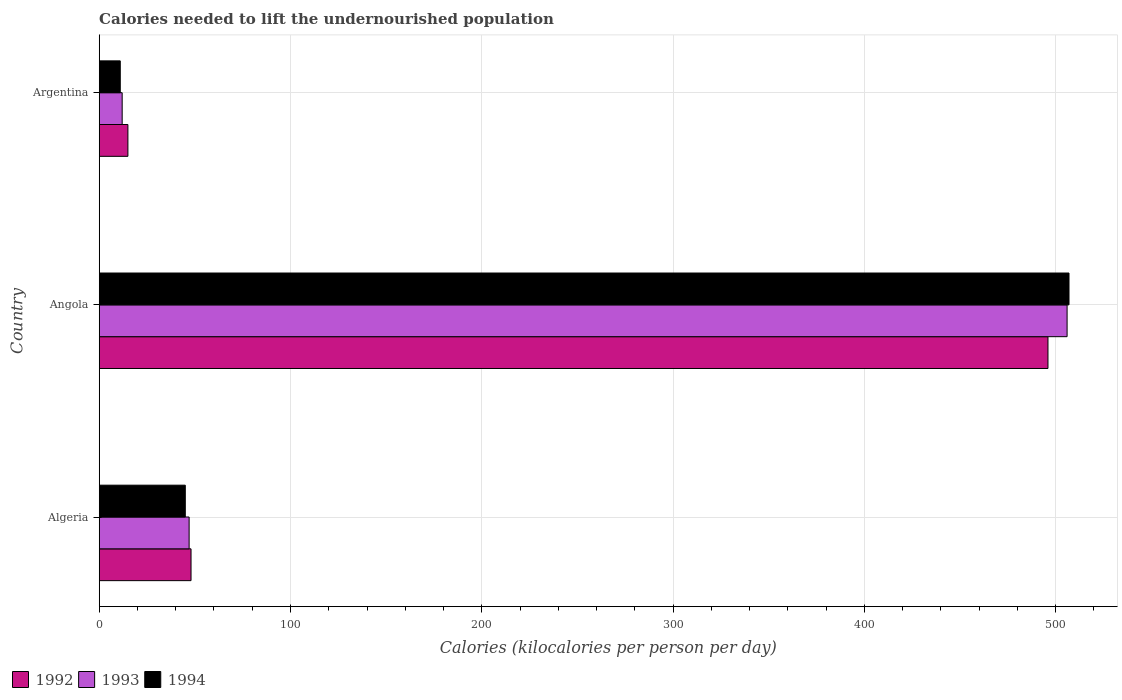How many groups of bars are there?
Ensure brevity in your answer.  3. Are the number of bars on each tick of the Y-axis equal?
Keep it short and to the point. Yes. How many bars are there on the 2nd tick from the top?
Provide a short and direct response. 3. How many bars are there on the 3rd tick from the bottom?
Offer a terse response. 3. In how many cases, is the number of bars for a given country not equal to the number of legend labels?
Give a very brief answer. 0. Across all countries, what is the maximum total calories needed to lift the undernourished population in 1994?
Ensure brevity in your answer.  507. Across all countries, what is the minimum total calories needed to lift the undernourished population in 1993?
Give a very brief answer. 12. In which country was the total calories needed to lift the undernourished population in 1992 maximum?
Your answer should be very brief. Angola. What is the total total calories needed to lift the undernourished population in 1994 in the graph?
Provide a short and direct response. 563. What is the difference between the total calories needed to lift the undernourished population in 1993 in Angola and that in Argentina?
Offer a very short reply. 494. What is the difference between the total calories needed to lift the undernourished population in 1992 in Algeria and the total calories needed to lift the undernourished population in 1993 in Angola?
Your answer should be compact. -458. What is the average total calories needed to lift the undernourished population in 1993 per country?
Offer a very short reply. 188.33. In how many countries, is the total calories needed to lift the undernourished population in 1994 greater than 200 kilocalories?
Ensure brevity in your answer.  1. What is the ratio of the total calories needed to lift the undernourished population in 1994 in Angola to that in Argentina?
Ensure brevity in your answer.  46.09. Is the total calories needed to lift the undernourished population in 1994 in Algeria less than that in Argentina?
Your answer should be compact. No. What is the difference between the highest and the second highest total calories needed to lift the undernourished population in 1994?
Give a very brief answer. 462. What is the difference between the highest and the lowest total calories needed to lift the undernourished population in 1993?
Your response must be concise. 494. What does the 2nd bar from the bottom in Algeria represents?
Offer a very short reply. 1993. Is it the case that in every country, the sum of the total calories needed to lift the undernourished population in 1993 and total calories needed to lift the undernourished population in 1994 is greater than the total calories needed to lift the undernourished population in 1992?
Your response must be concise. Yes. How many bars are there?
Make the answer very short. 9. Are all the bars in the graph horizontal?
Your answer should be very brief. Yes. How many countries are there in the graph?
Give a very brief answer. 3. What is the difference between two consecutive major ticks on the X-axis?
Provide a short and direct response. 100. Does the graph contain grids?
Keep it short and to the point. Yes. How many legend labels are there?
Your answer should be very brief. 3. How are the legend labels stacked?
Give a very brief answer. Horizontal. What is the title of the graph?
Provide a short and direct response. Calories needed to lift the undernourished population. What is the label or title of the X-axis?
Ensure brevity in your answer.  Calories (kilocalories per person per day). What is the Calories (kilocalories per person per day) in 1993 in Algeria?
Give a very brief answer. 47. What is the Calories (kilocalories per person per day) of 1992 in Angola?
Offer a very short reply. 496. What is the Calories (kilocalories per person per day) of 1993 in Angola?
Keep it short and to the point. 506. What is the Calories (kilocalories per person per day) of 1994 in Angola?
Your answer should be compact. 507. What is the Calories (kilocalories per person per day) of 1992 in Argentina?
Offer a terse response. 15. Across all countries, what is the maximum Calories (kilocalories per person per day) of 1992?
Provide a succinct answer. 496. Across all countries, what is the maximum Calories (kilocalories per person per day) of 1993?
Make the answer very short. 506. Across all countries, what is the maximum Calories (kilocalories per person per day) of 1994?
Make the answer very short. 507. What is the total Calories (kilocalories per person per day) of 1992 in the graph?
Ensure brevity in your answer.  559. What is the total Calories (kilocalories per person per day) in 1993 in the graph?
Give a very brief answer. 565. What is the total Calories (kilocalories per person per day) of 1994 in the graph?
Provide a succinct answer. 563. What is the difference between the Calories (kilocalories per person per day) of 1992 in Algeria and that in Angola?
Ensure brevity in your answer.  -448. What is the difference between the Calories (kilocalories per person per day) in 1993 in Algeria and that in Angola?
Make the answer very short. -459. What is the difference between the Calories (kilocalories per person per day) in 1994 in Algeria and that in Angola?
Provide a short and direct response. -462. What is the difference between the Calories (kilocalories per person per day) in 1993 in Algeria and that in Argentina?
Provide a short and direct response. 35. What is the difference between the Calories (kilocalories per person per day) of 1994 in Algeria and that in Argentina?
Offer a terse response. 34. What is the difference between the Calories (kilocalories per person per day) in 1992 in Angola and that in Argentina?
Offer a terse response. 481. What is the difference between the Calories (kilocalories per person per day) of 1993 in Angola and that in Argentina?
Your answer should be compact. 494. What is the difference between the Calories (kilocalories per person per day) in 1994 in Angola and that in Argentina?
Make the answer very short. 496. What is the difference between the Calories (kilocalories per person per day) of 1992 in Algeria and the Calories (kilocalories per person per day) of 1993 in Angola?
Offer a terse response. -458. What is the difference between the Calories (kilocalories per person per day) in 1992 in Algeria and the Calories (kilocalories per person per day) in 1994 in Angola?
Your answer should be compact. -459. What is the difference between the Calories (kilocalories per person per day) in 1993 in Algeria and the Calories (kilocalories per person per day) in 1994 in Angola?
Make the answer very short. -460. What is the difference between the Calories (kilocalories per person per day) in 1992 in Algeria and the Calories (kilocalories per person per day) in 1993 in Argentina?
Offer a very short reply. 36. What is the difference between the Calories (kilocalories per person per day) of 1992 in Algeria and the Calories (kilocalories per person per day) of 1994 in Argentina?
Provide a succinct answer. 37. What is the difference between the Calories (kilocalories per person per day) in 1992 in Angola and the Calories (kilocalories per person per day) in 1993 in Argentina?
Your response must be concise. 484. What is the difference between the Calories (kilocalories per person per day) in 1992 in Angola and the Calories (kilocalories per person per day) in 1994 in Argentina?
Your response must be concise. 485. What is the difference between the Calories (kilocalories per person per day) of 1993 in Angola and the Calories (kilocalories per person per day) of 1994 in Argentina?
Give a very brief answer. 495. What is the average Calories (kilocalories per person per day) in 1992 per country?
Keep it short and to the point. 186.33. What is the average Calories (kilocalories per person per day) in 1993 per country?
Provide a succinct answer. 188.33. What is the average Calories (kilocalories per person per day) of 1994 per country?
Your response must be concise. 187.67. What is the difference between the Calories (kilocalories per person per day) in 1992 and Calories (kilocalories per person per day) in 1994 in Algeria?
Your answer should be compact. 3. What is the difference between the Calories (kilocalories per person per day) of 1992 and Calories (kilocalories per person per day) of 1993 in Angola?
Offer a very short reply. -10. What is the difference between the Calories (kilocalories per person per day) in 1993 and Calories (kilocalories per person per day) in 1994 in Angola?
Your response must be concise. -1. What is the difference between the Calories (kilocalories per person per day) in 1992 and Calories (kilocalories per person per day) in 1994 in Argentina?
Ensure brevity in your answer.  4. What is the ratio of the Calories (kilocalories per person per day) of 1992 in Algeria to that in Angola?
Your response must be concise. 0.1. What is the ratio of the Calories (kilocalories per person per day) in 1993 in Algeria to that in Angola?
Your answer should be compact. 0.09. What is the ratio of the Calories (kilocalories per person per day) in 1994 in Algeria to that in Angola?
Provide a short and direct response. 0.09. What is the ratio of the Calories (kilocalories per person per day) of 1992 in Algeria to that in Argentina?
Your response must be concise. 3.2. What is the ratio of the Calories (kilocalories per person per day) of 1993 in Algeria to that in Argentina?
Offer a very short reply. 3.92. What is the ratio of the Calories (kilocalories per person per day) in 1994 in Algeria to that in Argentina?
Provide a succinct answer. 4.09. What is the ratio of the Calories (kilocalories per person per day) of 1992 in Angola to that in Argentina?
Make the answer very short. 33.07. What is the ratio of the Calories (kilocalories per person per day) in 1993 in Angola to that in Argentina?
Your answer should be compact. 42.17. What is the ratio of the Calories (kilocalories per person per day) of 1994 in Angola to that in Argentina?
Offer a very short reply. 46.09. What is the difference between the highest and the second highest Calories (kilocalories per person per day) of 1992?
Provide a short and direct response. 448. What is the difference between the highest and the second highest Calories (kilocalories per person per day) in 1993?
Make the answer very short. 459. What is the difference between the highest and the second highest Calories (kilocalories per person per day) of 1994?
Offer a very short reply. 462. What is the difference between the highest and the lowest Calories (kilocalories per person per day) of 1992?
Your answer should be very brief. 481. What is the difference between the highest and the lowest Calories (kilocalories per person per day) in 1993?
Your answer should be very brief. 494. What is the difference between the highest and the lowest Calories (kilocalories per person per day) in 1994?
Give a very brief answer. 496. 